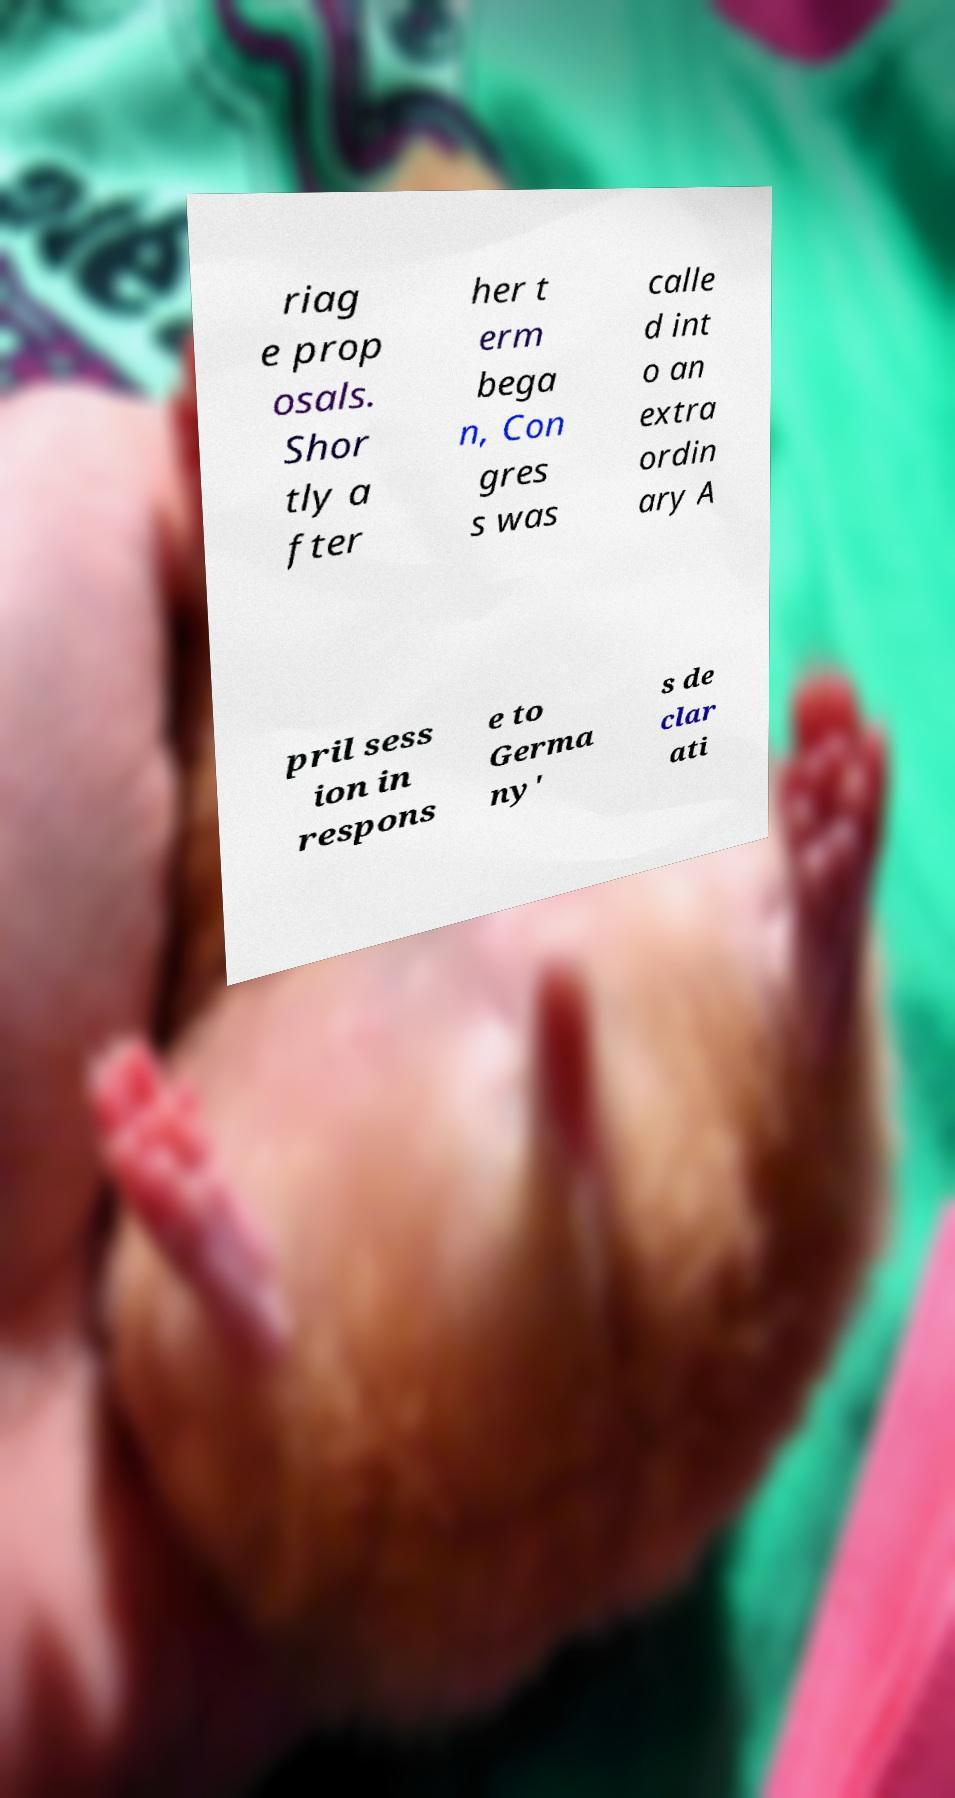Could you assist in decoding the text presented in this image and type it out clearly? riag e prop osals. Shor tly a fter her t erm bega n, Con gres s was calle d int o an extra ordin ary A pril sess ion in respons e to Germa ny' s de clar ati 